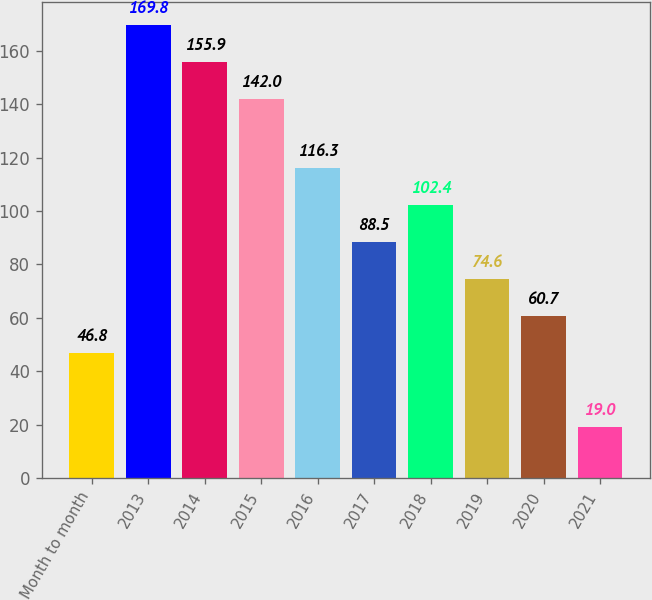<chart> <loc_0><loc_0><loc_500><loc_500><bar_chart><fcel>Month to month<fcel>2013<fcel>2014<fcel>2015<fcel>2016<fcel>2017<fcel>2018<fcel>2019<fcel>2020<fcel>2021<nl><fcel>46.8<fcel>169.8<fcel>155.9<fcel>142<fcel>116.3<fcel>88.5<fcel>102.4<fcel>74.6<fcel>60.7<fcel>19<nl></chart> 